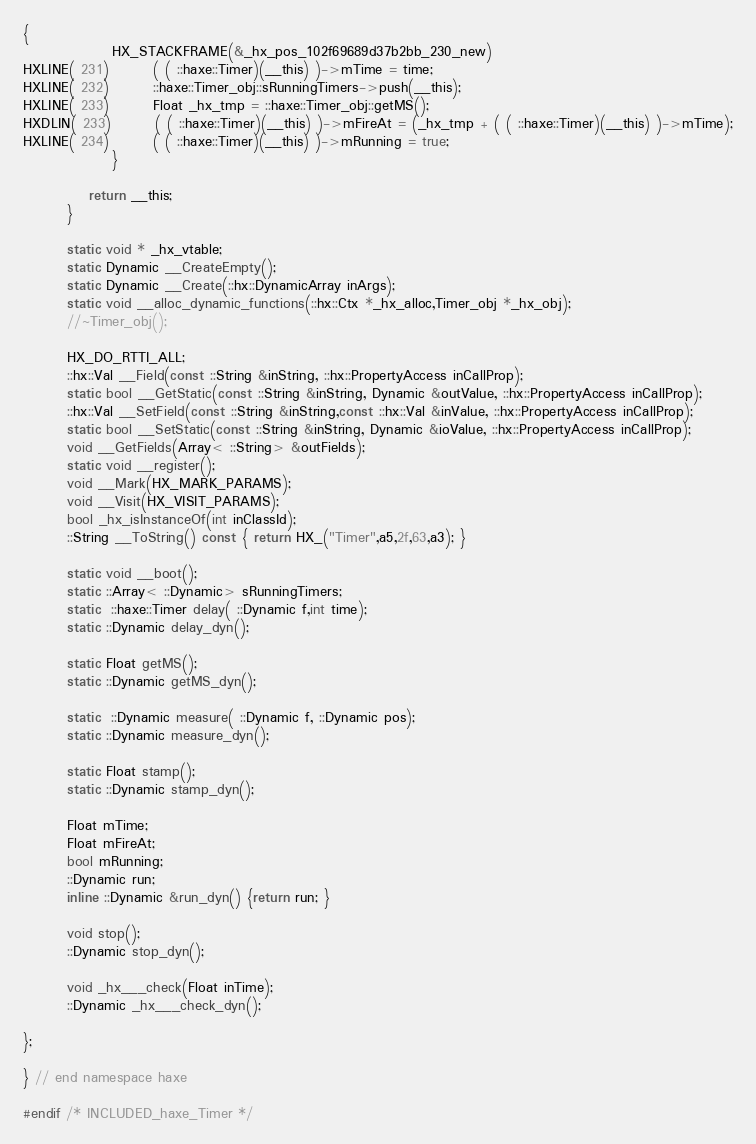<code> <loc_0><loc_0><loc_500><loc_500><_C_>{
            	HX_STACKFRAME(&_hx_pos_102f69689d37b2bb_230_new)
HXLINE( 231)		( ( ::haxe::Timer)(__this) )->mTime = time;
HXLINE( 232)		::haxe::Timer_obj::sRunningTimers->push(__this);
HXLINE( 233)		Float _hx_tmp = ::haxe::Timer_obj::getMS();
HXDLIN( 233)		( ( ::haxe::Timer)(__this) )->mFireAt = (_hx_tmp + ( ( ::haxe::Timer)(__this) )->mTime);
HXLINE( 234)		( ( ::haxe::Timer)(__this) )->mRunning = true;
            	}
		
			return __this;
		}

		static void * _hx_vtable;
		static Dynamic __CreateEmpty();
		static Dynamic __Create(::hx::DynamicArray inArgs);
		static void __alloc_dynamic_functions(::hx::Ctx *_hx_alloc,Timer_obj *_hx_obj);
		//~Timer_obj();

		HX_DO_RTTI_ALL;
		::hx::Val __Field(const ::String &inString, ::hx::PropertyAccess inCallProp);
		static bool __GetStatic(const ::String &inString, Dynamic &outValue, ::hx::PropertyAccess inCallProp);
		::hx::Val __SetField(const ::String &inString,const ::hx::Val &inValue, ::hx::PropertyAccess inCallProp);
		static bool __SetStatic(const ::String &inString, Dynamic &ioValue, ::hx::PropertyAccess inCallProp);
		void __GetFields(Array< ::String> &outFields);
		static void __register();
		void __Mark(HX_MARK_PARAMS);
		void __Visit(HX_VISIT_PARAMS);
		bool _hx_isInstanceOf(int inClassId);
		::String __ToString() const { return HX_("Timer",a5,2f,63,a3); }

		static void __boot();
		static ::Array< ::Dynamic> sRunningTimers;
		static  ::haxe::Timer delay( ::Dynamic f,int time);
		static ::Dynamic delay_dyn();

		static Float getMS();
		static ::Dynamic getMS_dyn();

		static  ::Dynamic measure( ::Dynamic f, ::Dynamic pos);
		static ::Dynamic measure_dyn();

		static Float stamp();
		static ::Dynamic stamp_dyn();

		Float mTime;
		Float mFireAt;
		bool mRunning;
		::Dynamic run;
		inline ::Dynamic &run_dyn() {return run; }

		void stop();
		::Dynamic stop_dyn();

		void _hx___check(Float inTime);
		::Dynamic _hx___check_dyn();

};

} // end namespace haxe

#endif /* INCLUDED_haxe_Timer */ 
</code> 